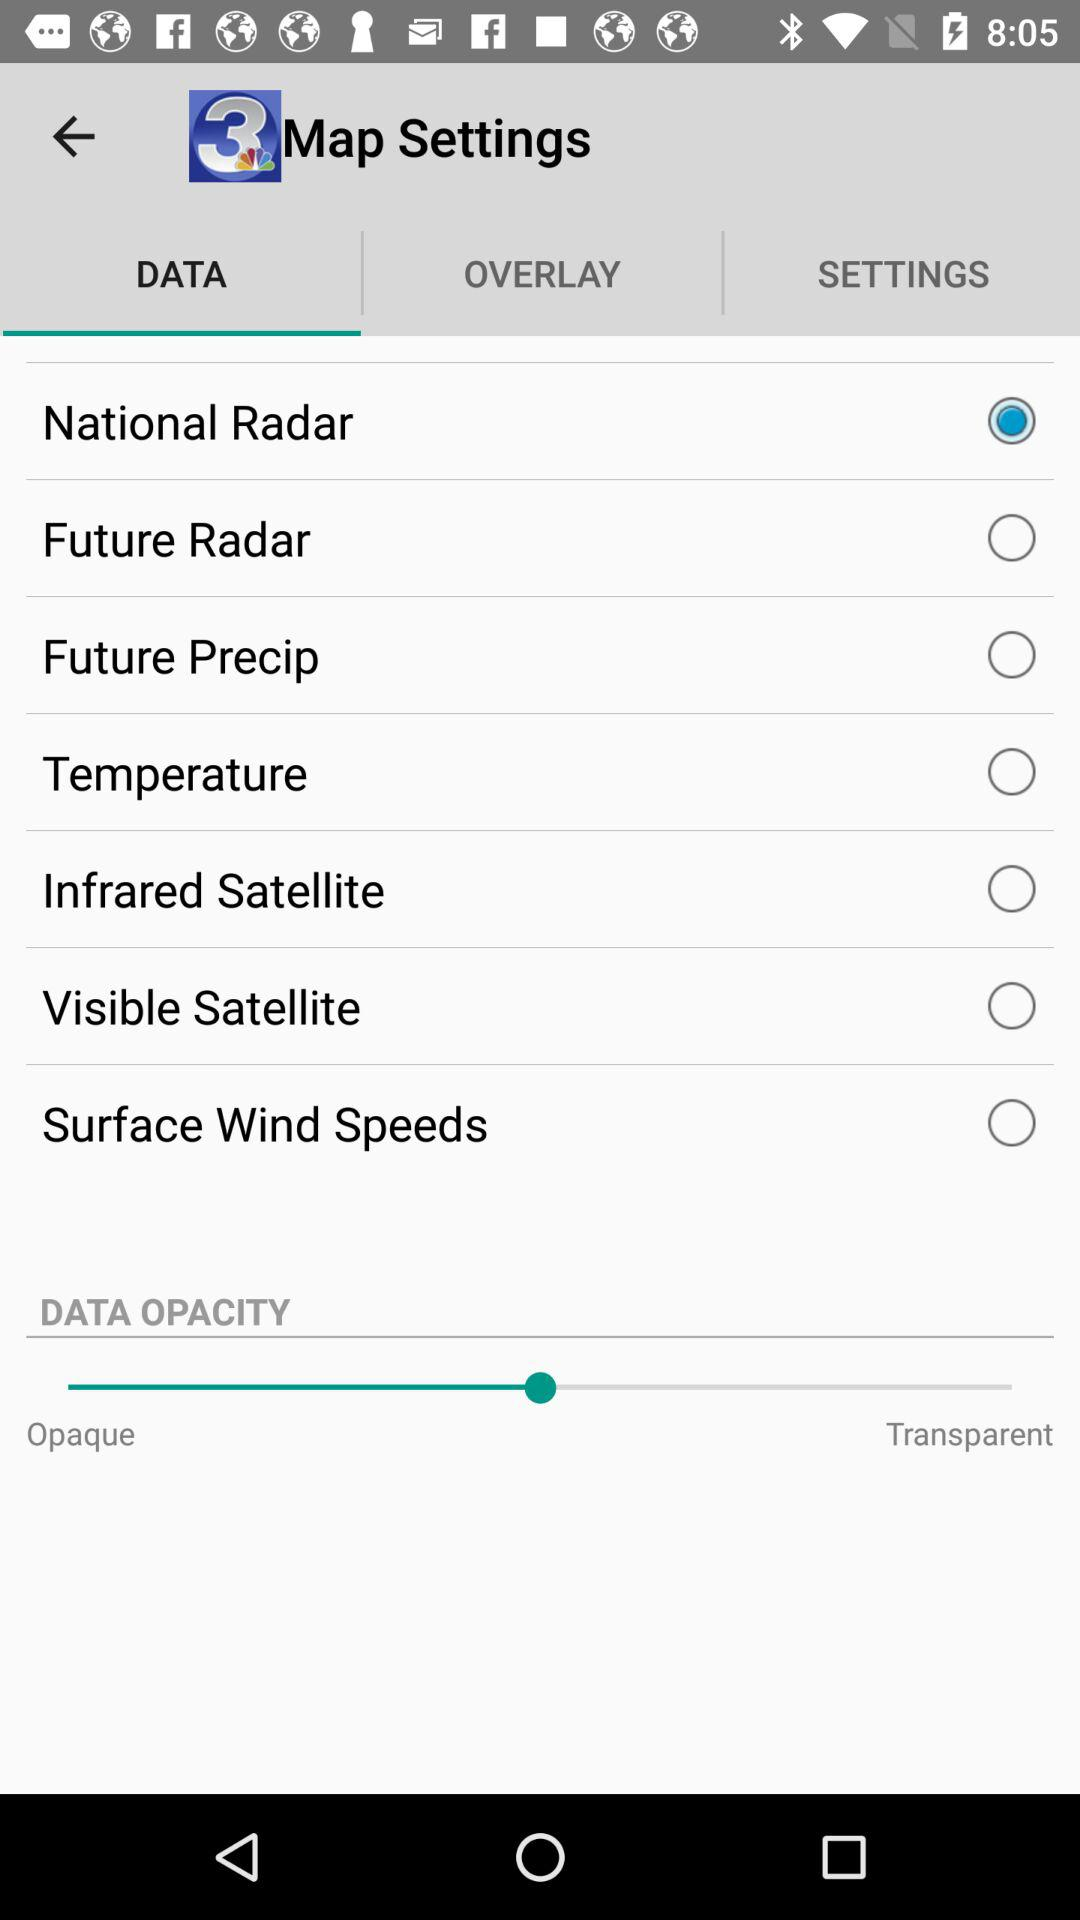Which option has been selected? The option that has been selected is "National Radar". 